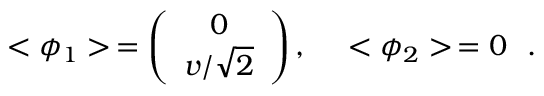<formula> <loc_0><loc_0><loc_500><loc_500>< \phi _ { 1 } > \, = \left ( \begin{array} { c } { 0 } \\ { { { v / \sqrt { 2 } } } } \end{array} \right ) , \quad < \phi _ { 2 } > \, = 0 \, .</formula> 